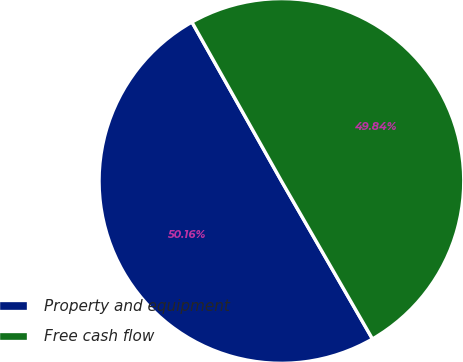Convert chart to OTSL. <chart><loc_0><loc_0><loc_500><loc_500><pie_chart><fcel>Property and equipment<fcel>Free cash flow<nl><fcel>50.16%<fcel>49.84%<nl></chart> 